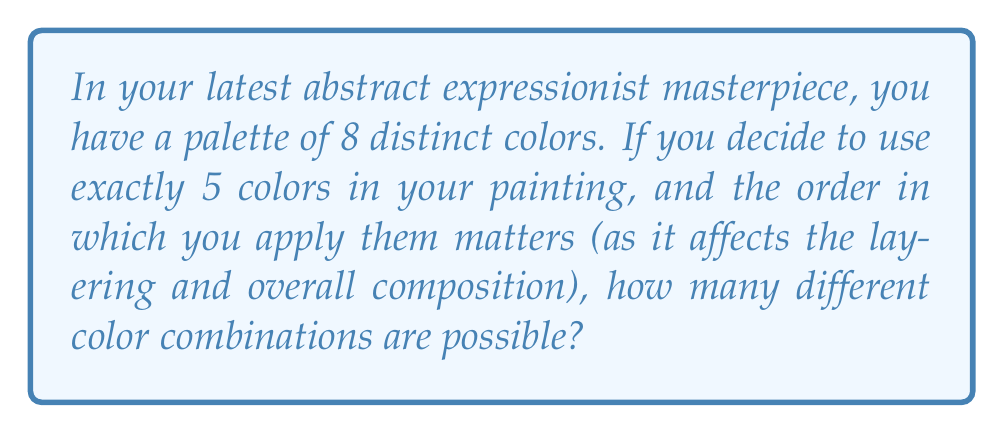Show me your answer to this math problem. Let's approach this step-by-step:

1) This is a permutation problem. We are selecting 5 colors from 8 and the order matters.

2) The formula for permutations is:

   $$P(n,r) = \frac{n!}{(n-r)!}$$

   Where $n$ is the total number of items to choose from, and $r$ is the number of items being chosen.

3) In this case, $n = 8$ (total colors) and $r = 5$ (colors used in the painting).

4) Substituting these values into the formula:

   $$P(8,5) = \frac{8!}{(8-5)!} = \frac{8!}{3!}$$

5) Expanding this:
   
   $$\frac{8 \cdot 7 \cdot 6 \cdot 5 \cdot 4 \cdot 3!}{3!}$$

6) The $3!$ cancels out in the numerator and denominator:

   $$8 \cdot 7 \cdot 6 \cdot 5 \cdot 4 = 6720$$

Therefore, there are 6720 possible color combinations for your abstract expressionist painting.
Answer: 6720 